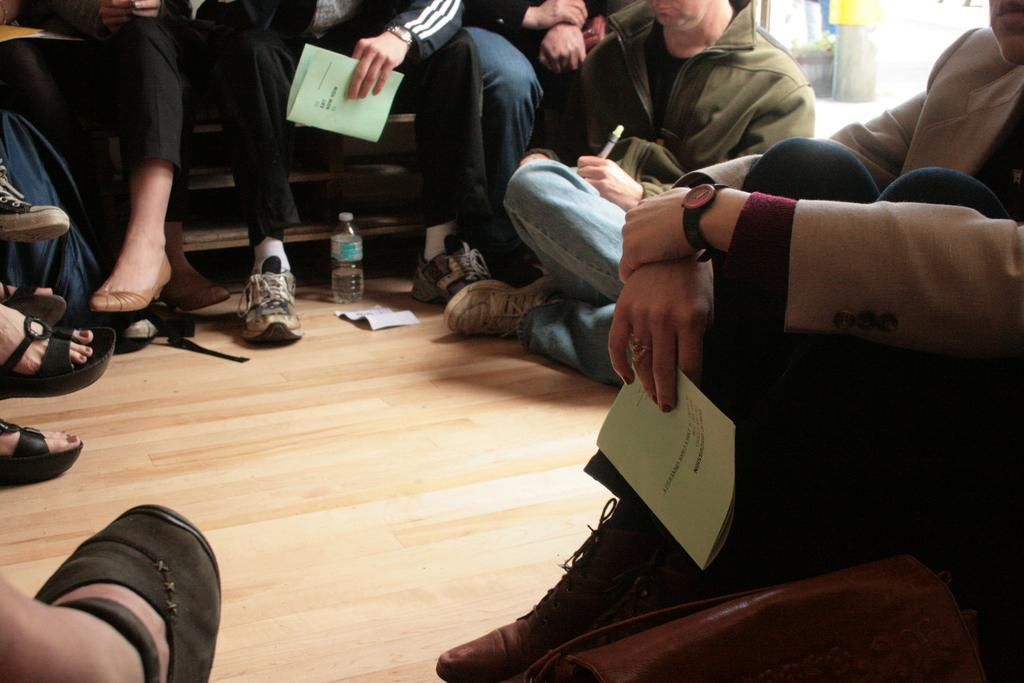What is the main subject of the image? The main subject of the image is a group of people. Can you describe any objects present in the image? Yes, there is a bottle in the image. What are some people in the image holding? Some people in the image are holding papers and pens. How many children are playing on the floor in the image? There are no children or floor present in the image; it features a group of people and a bottle. What is the percentage of people in the image that are increasing their knowledge? The image does not provide information about the knowledge level of the people, so it cannot be determined if anyone is increasing their knowledge. 